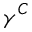<formula> <loc_0><loc_0><loc_500><loc_500>\gamma ^ { C }</formula> 